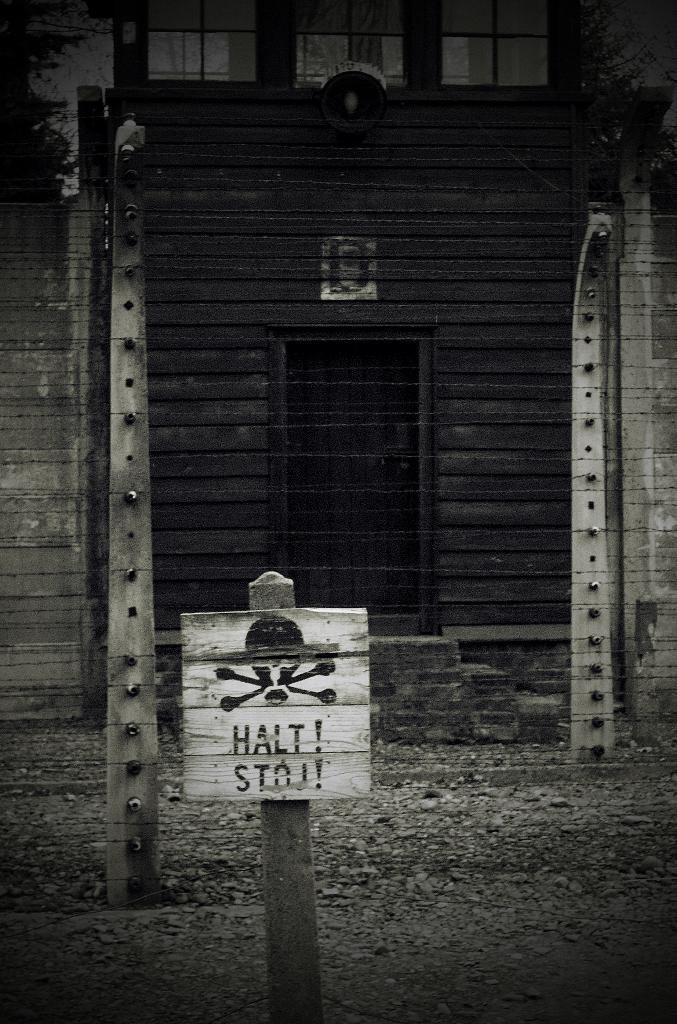What is located in the foreground of the image? There is a sign board in the foreground of the image. How is the sign board supported? The sign board is placed on a pole. What can be seen in the background of the image? There is a fence, a building with windows, a door, and a lamp in the background of the image. What type of sack is being used to carry the tub in the image? There is no sack or tub present in the image. 